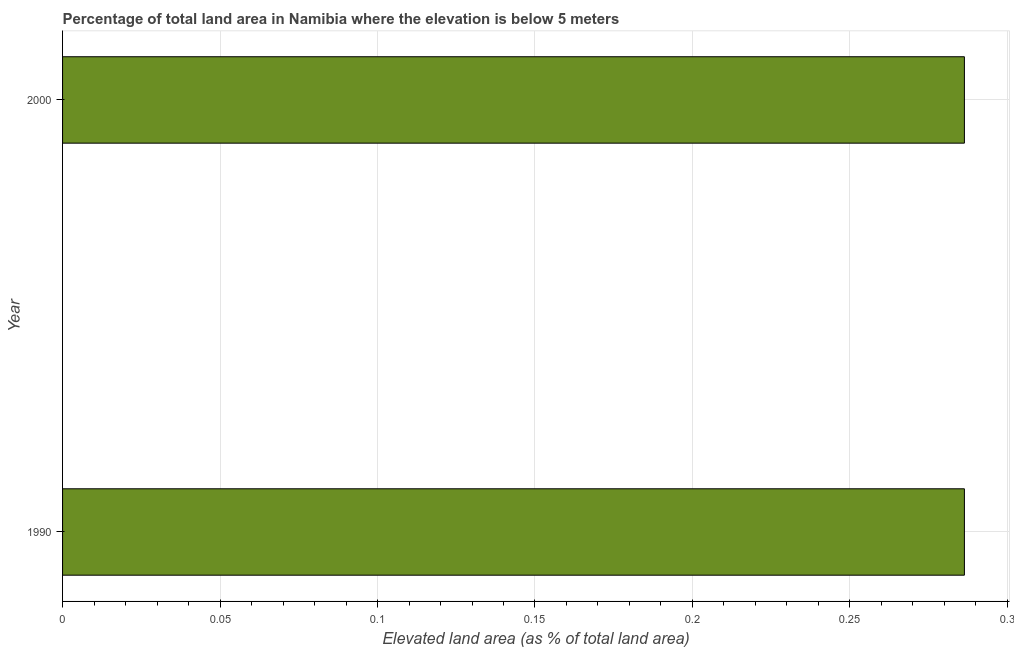Does the graph contain grids?
Give a very brief answer. Yes. What is the title of the graph?
Give a very brief answer. Percentage of total land area in Namibia where the elevation is below 5 meters. What is the label or title of the X-axis?
Give a very brief answer. Elevated land area (as % of total land area). What is the total elevated land area in 2000?
Offer a very short reply. 0.29. Across all years, what is the maximum total elevated land area?
Offer a terse response. 0.29. Across all years, what is the minimum total elevated land area?
Your answer should be compact. 0.29. What is the sum of the total elevated land area?
Your response must be concise. 0.57. What is the difference between the total elevated land area in 1990 and 2000?
Make the answer very short. 0. What is the average total elevated land area per year?
Offer a very short reply. 0.29. What is the median total elevated land area?
Keep it short and to the point. 0.29. In how many years, is the total elevated land area greater than 0.11 %?
Make the answer very short. 2. Do a majority of the years between 1990 and 2000 (inclusive) have total elevated land area greater than 0.01 %?
Your response must be concise. Yes. In how many years, is the total elevated land area greater than the average total elevated land area taken over all years?
Ensure brevity in your answer.  0. Are all the bars in the graph horizontal?
Provide a short and direct response. Yes. What is the Elevated land area (as % of total land area) of 1990?
Give a very brief answer. 0.29. What is the Elevated land area (as % of total land area) of 2000?
Give a very brief answer. 0.29. 